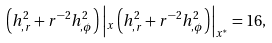Convert formula to latex. <formula><loc_0><loc_0><loc_500><loc_500>\left ( h _ { , r } ^ { 2 } + r ^ { - 2 } h _ { , \phi } ^ { 2 } \right ) \left | _ { x } \left ( h _ { , r } ^ { 2 } + r ^ { - 2 } h _ { , \phi } ^ { 2 } \right ) \right | _ { x ^ { ^ { * } } } = 1 6 ,</formula> 